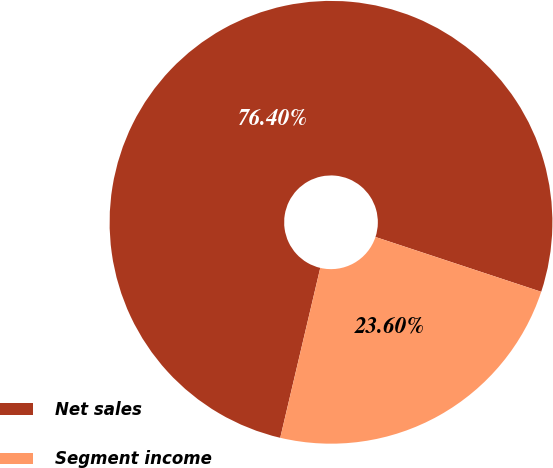Convert chart to OTSL. <chart><loc_0><loc_0><loc_500><loc_500><pie_chart><fcel>Net sales<fcel>Segment income<nl><fcel>76.4%<fcel>23.6%<nl></chart> 